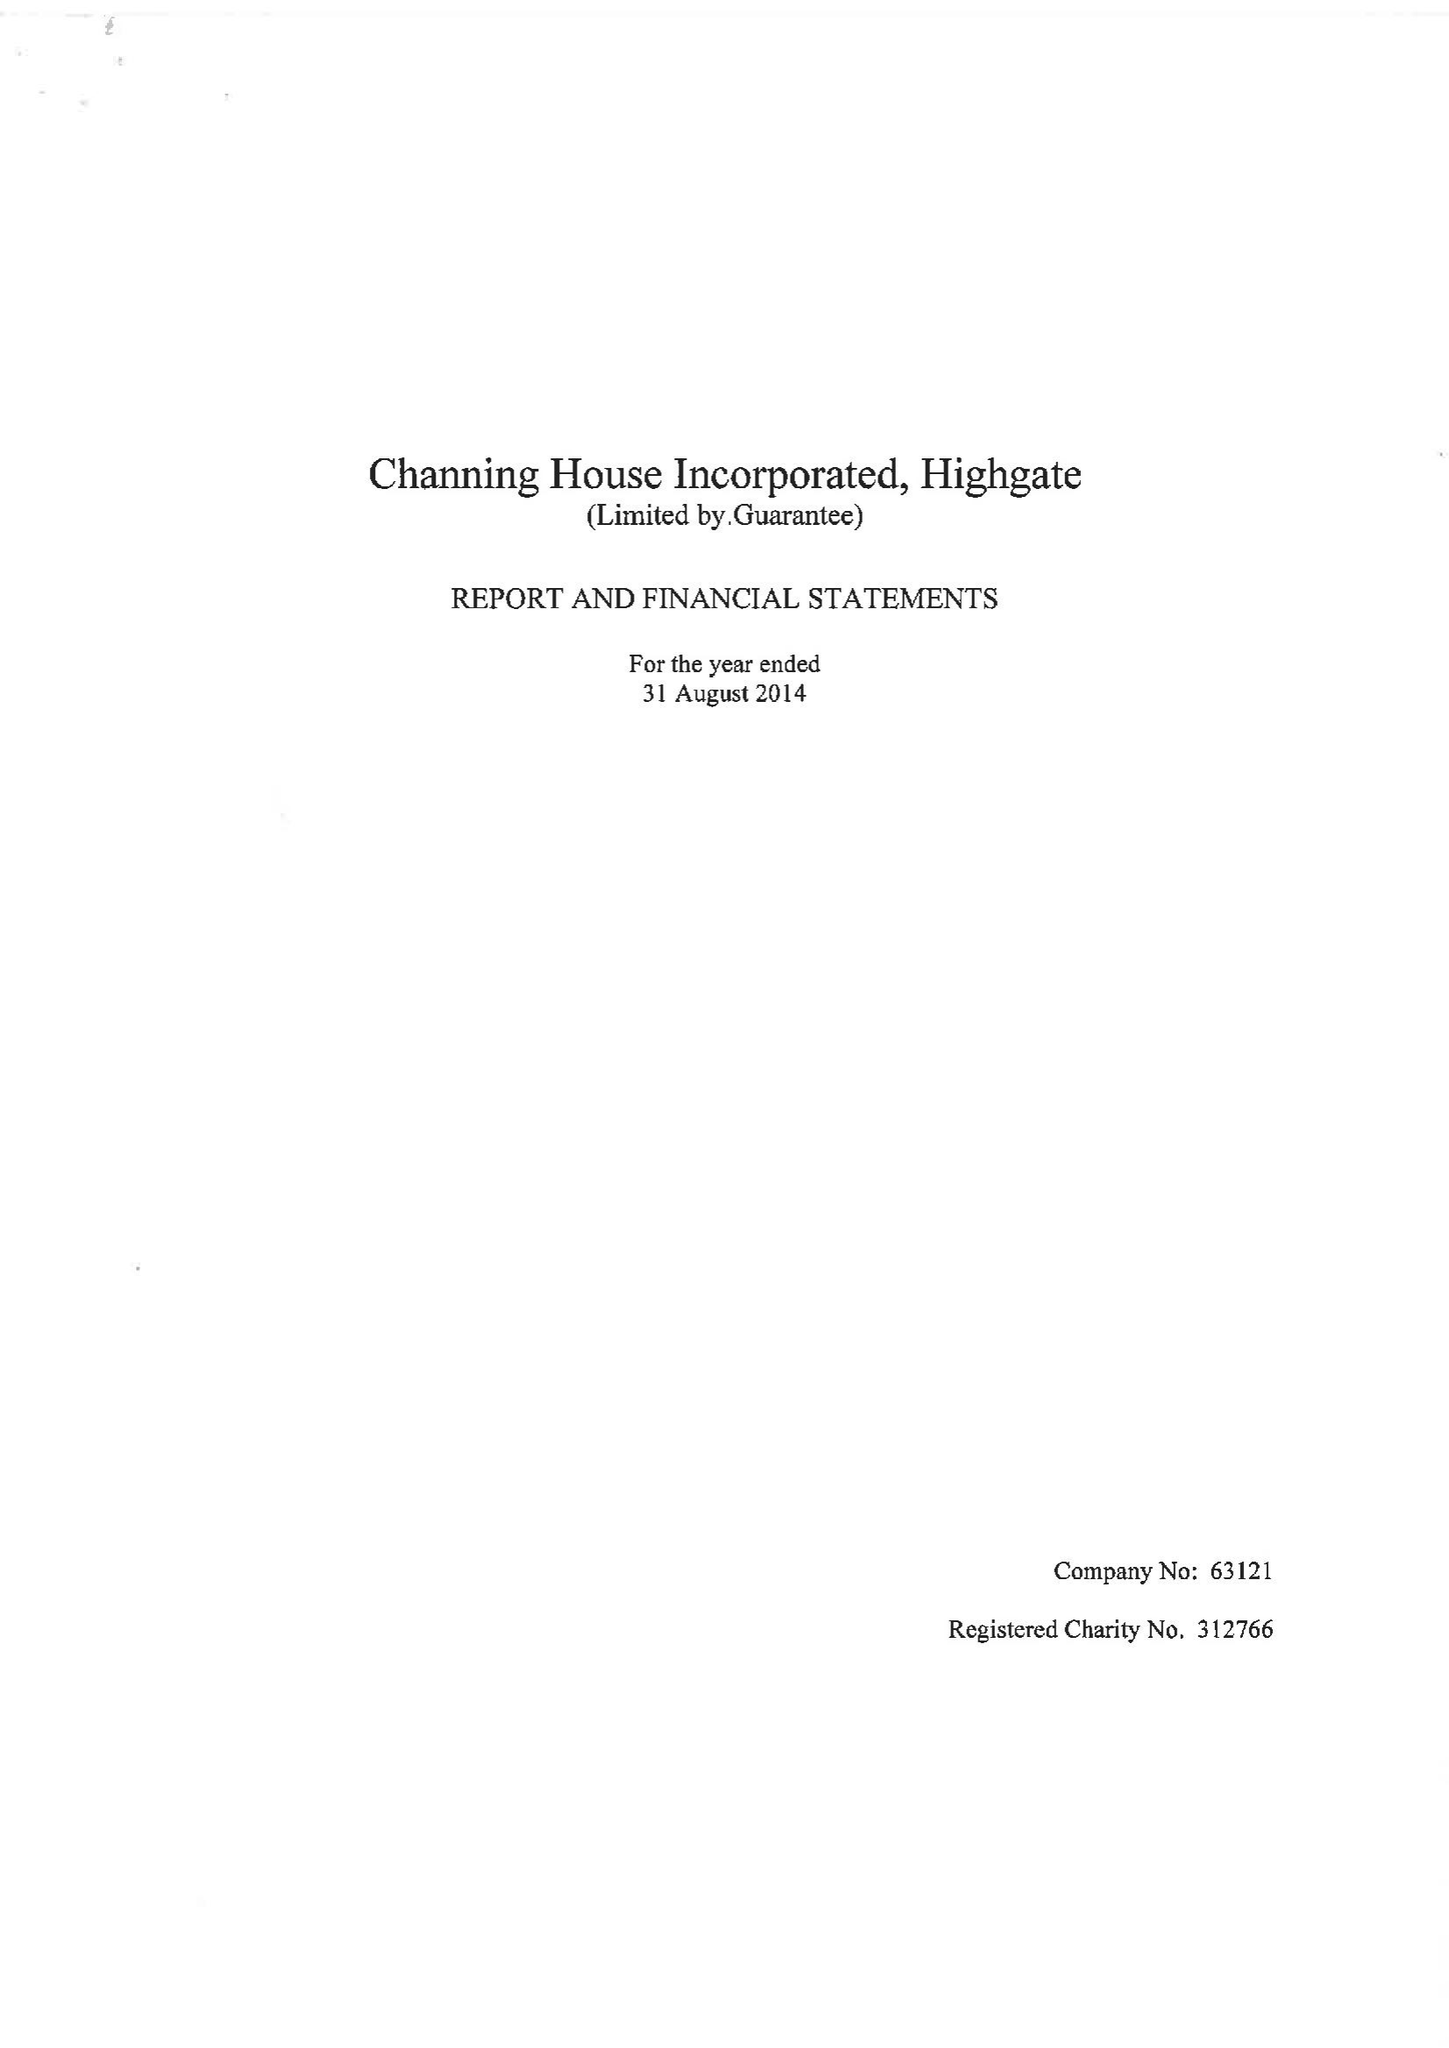What is the value for the spending_annually_in_british_pounds?
Answer the question using a single word or phrase. 9125915.00 